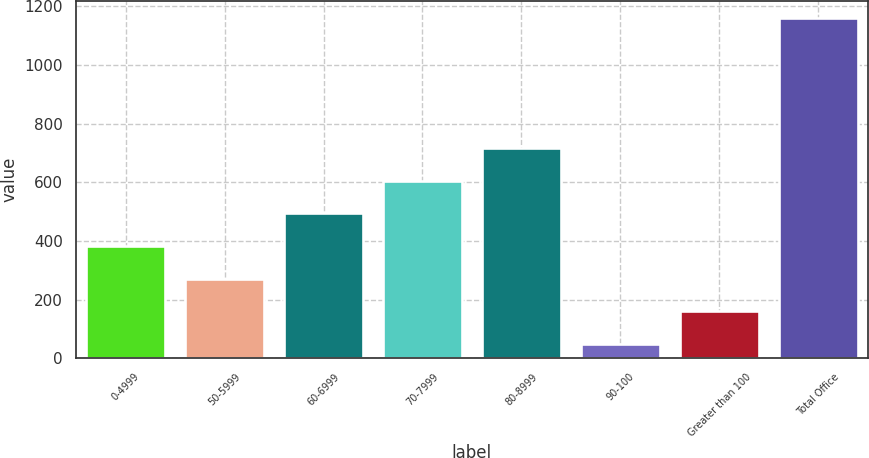Convert chart to OTSL. <chart><loc_0><loc_0><loc_500><loc_500><bar_chart><fcel>0-4999<fcel>50-5999<fcel>60-6999<fcel>70-7999<fcel>80-8999<fcel>90-100<fcel>Greater than 100<fcel>Total Office<nl><fcel>383.6<fcel>272.4<fcel>494.8<fcel>606<fcel>717.2<fcel>50<fcel>161.2<fcel>1162<nl></chart> 